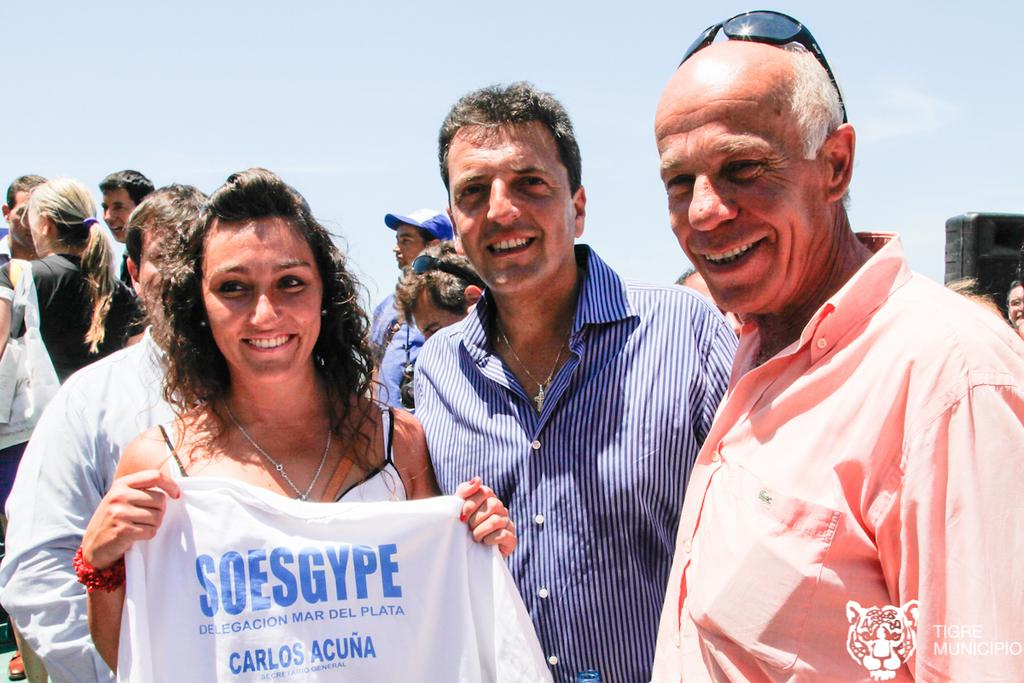Who or what can be seen in the image? There are people in the image. What are the people doing in the image? The people are standing. What is the facial expression of the people in the image? The people are smiling. What type of boats can be seen in the image? There are no boats present in the image; it features people standing and smiling. What activity are the people participating in while tricking each other in the image? There is no trick or activity involving boats mentioned in the image. 